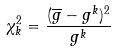<formula> <loc_0><loc_0><loc_500><loc_500>\chi _ { k } ^ { 2 } = \frac { ( \overline { g } - g ^ { k } ) ^ { 2 } } { g ^ { k } }</formula> 